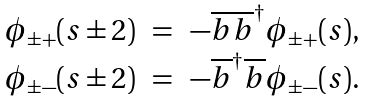<formula> <loc_0><loc_0><loc_500><loc_500>\begin{array} { r c l } \phi _ { \pm + } ( s \pm 2 ) & = & - \overline { b } \overline { b } ^ { \dagger } \phi _ { \pm + } ( s ) , \\ \phi _ { \pm - } ( s \pm 2 ) & = & - \overline { b } ^ { \dagger } \overline { b } \phi _ { \pm - } ( s ) . \end{array}</formula> 